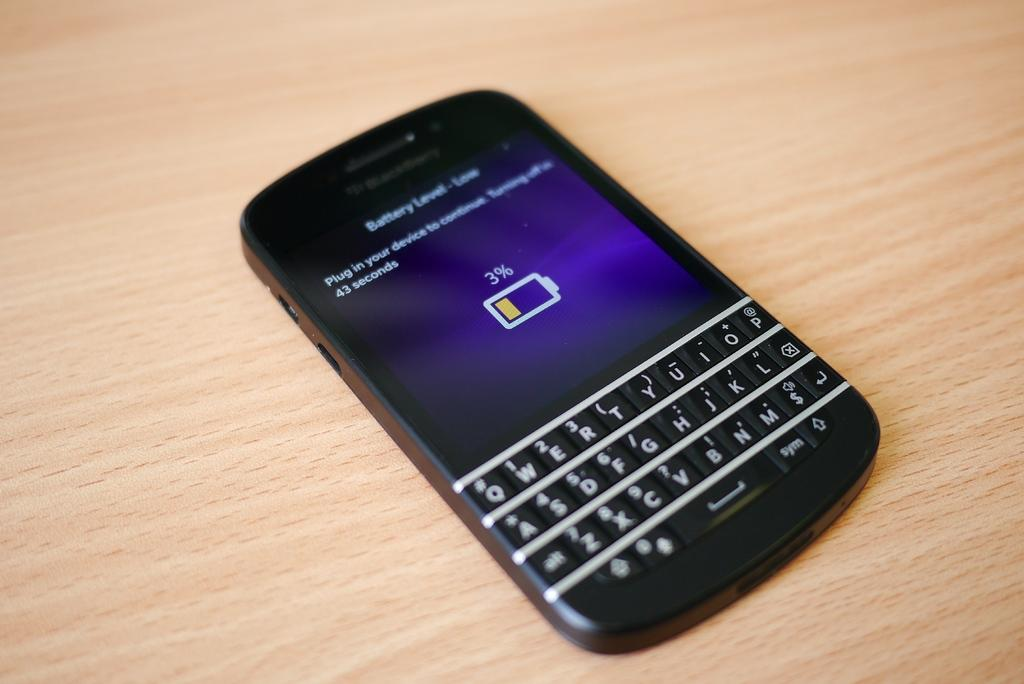<image>
Create a compact narrative representing the image presented. a black blackberry phone that says 'battery level-low' on the screen 